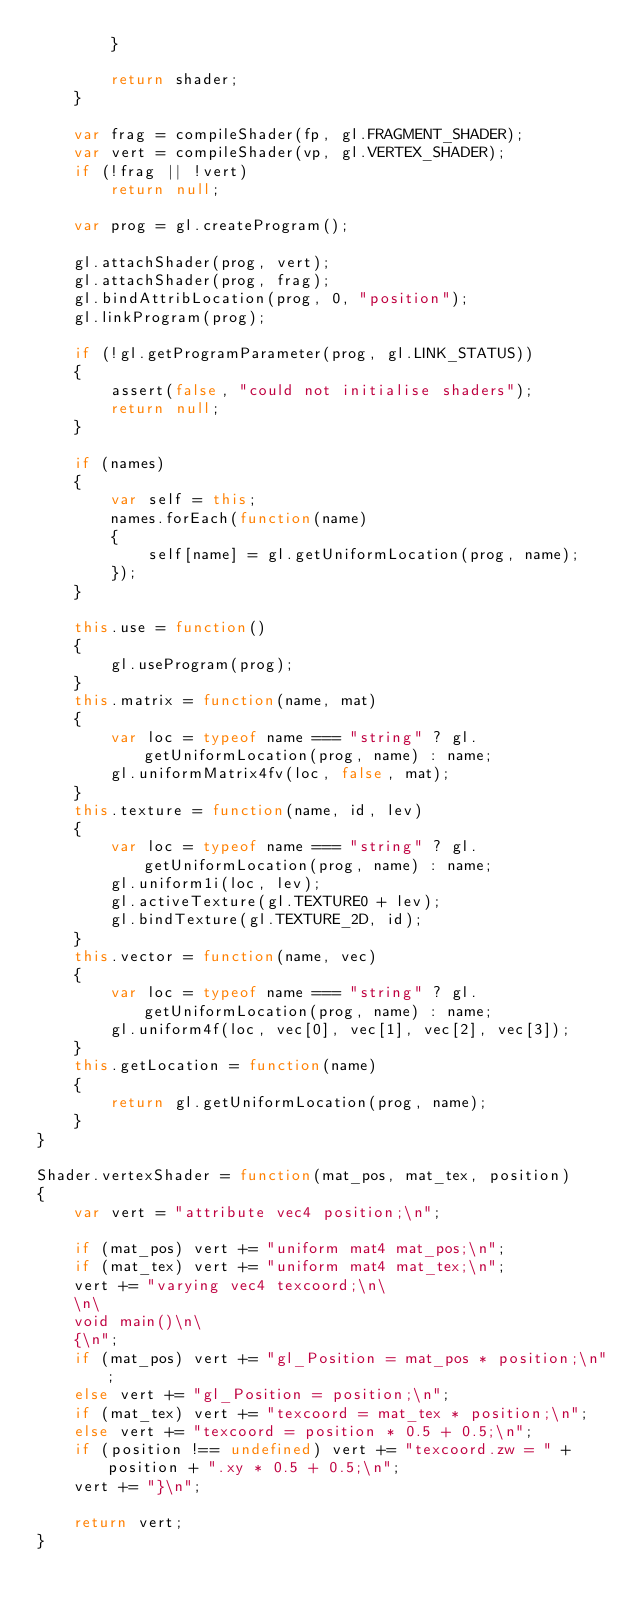<code> <loc_0><loc_0><loc_500><loc_500><_JavaScript_>        }

        return shader;
    }
    
    var frag = compileShader(fp, gl.FRAGMENT_SHADER);
    var vert = compileShader(vp, gl.VERTEX_SHADER);
    if (!frag || !vert)
        return null;

    var prog = gl.createProgram();
        
    gl.attachShader(prog, vert);
    gl.attachShader(prog, frag);
    gl.bindAttribLocation(prog, 0, "position");
    gl.linkProgram(prog);

    if (!gl.getProgramParameter(prog, gl.LINK_STATUS))
    {
        assert(false, "could not initialise shaders");
        return null;
    }

    if (names)
    {
        var self = this;
        names.forEach(function(name)
        {
            self[name] = gl.getUniformLocation(prog, name);
        });
    }
    
    this.use = function()
    {
        gl.useProgram(prog);
    }
    this.matrix = function(name, mat)
    {
        var loc = typeof name === "string" ? gl.getUniformLocation(prog, name) : name;
        gl.uniformMatrix4fv(loc, false, mat); 
    }
    this.texture = function(name, id, lev)
    {
        var loc = typeof name === "string" ? gl.getUniformLocation(prog, name) : name;
        gl.uniform1i(loc, lev);
        gl.activeTexture(gl.TEXTURE0 + lev);
        gl.bindTexture(gl.TEXTURE_2D, id);
    }
    this.vector = function(name, vec)
    {
        var loc = typeof name === "string" ? gl.getUniformLocation(prog, name) : name;
        gl.uniform4f(loc, vec[0], vec[1], vec[2], vec[3]);
    }
    this.getLocation = function(name)
    {
        return gl.getUniformLocation(prog, name);
    }
}

Shader.vertexShader = function(mat_pos, mat_tex, position)
{
    var vert = "attribute vec4 position;\n";

    if (mat_pos) vert += "uniform mat4 mat_pos;\n";
    if (mat_tex) vert += "uniform mat4 mat_tex;\n";
    vert += "varying vec4 texcoord;\n\
    \n\
    void main()\n\
    {\n";
    if (mat_pos) vert += "gl_Position = mat_pos * position;\n";
    else vert += "gl_Position = position;\n";
    if (mat_tex) vert += "texcoord = mat_tex * position;\n";
    else vert += "texcoord = position * 0.5 + 0.5;\n";
    if (position !== undefined) vert += "texcoord.zw = " + position + ".xy * 0.5 + 0.5;\n";
    vert += "}\n";

    return vert;
}</code> 